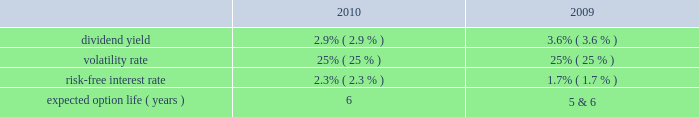Tax benefits recognized for stock-based compensation during the years ended december 31 , 2011 , 2010 and 2009 , were $ 16 million , $ 6 million and $ 5 million , respectively .
The amount of northrop grumman shares issued before the spin-off to satisfy stock-based compensation awards are recorded by northrop grumman and , accordingly , are not reflected in hii 2019s consolidated financial statements .
The company realized tax benefits during the year ended december 31 , 2011 , of $ 2 million from the exercise of stock options and $ 10 million from the issuance of stock in settlement of rpsrs and rsrs .
Unrecognized compensation expense at december 31 , 2011 there was $ 1 million of unrecognized compensation expense related to unvested stock option awards , which will be recognized over a weighted average period of 1.1 years .
In addition , at december 31 , 2011 , there was $ 19 million of unrecognized compensation expense associated with the 2011 rsrs , which will be recognized over a period of 2.2 years ; $ 10 million of unrecognized compensation expense associated with the rpsrs converted as part of the spin-off , which will be recognized over a weighted average period of one year ; and $ 18 million of unrecognized compensation expense associated with the 2011 rpsrs which will be recognized over a period of 2.0 years .
Stock options the compensation expense for the outstanding converted stock options was determined at the time of grant by northrop grumman .
There were no additional options granted during the year ended december 31 , 2011 .
The fair value of the stock option awards is expensed on a straight-line basis over the vesting period of the options .
The fair value of each of the stock option award was estimated on the date of grant using a black-scholes option pricing model based on the following assumptions : dividend yield 2014the dividend yield was based on northrop grumman 2019s historical dividend yield level .
Volatility 2014expected volatility was based on the average of the implied volatility from traded options and the historical volatility of northrop grumman 2019s stock .
Risk-free interest rate 2014the risk-free rate for periods within the contractual life of the stock option award was based on the yield curve of a zero-coupon u.s .
Treasury bond on the date the award was granted with a maturity equal to the expected term of the award .
Expected term 2014the expected term of awards granted was derived from historical experience and represents the period of time that awards granted are expected to be outstanding .
A stratification of expected terms based on employee populations ( executive and non-executive ) was considered in the analysis .
The following significant weighted-average assumptions were used to value stock options granted during the years ended december 31 , 2010 and 2009: .
The weighted-average grant date fair value of stock options granted during the years ended december 31 , 2010 and 2009 , was $ 11 and $ 7 , per share , respectively. .
At december 312011 what was the ratio of the unrecognized compensation expense associated of rsrs to the rpsrs? 
Rationale: for every $ 1.9 of unrecognized compensation expense associated rsrs there was $ 1
Computations: (19 / 10)
Answer: 1.9. 